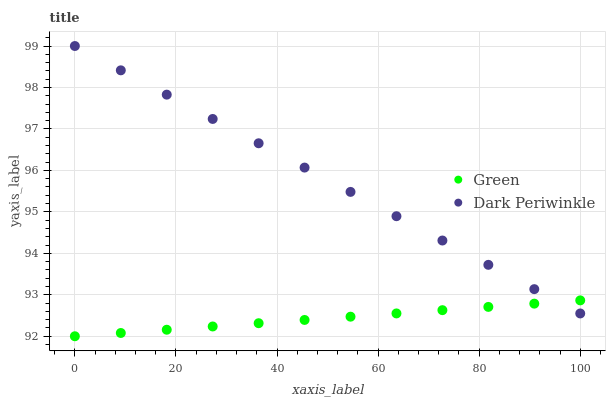Does Green have the minimum area under the curve?
Answer yes or no. Yes. Does Dark Periwinkle have the maximum area under the curve?
Answer yes or no. Yes. Does Dark Periwinkle have the minimum area under the curve?
Answer yes or no. No. Is Dark Periwinkle the smoothest?
Answer yes or no. Yes. Is Green the roughest?
Answer yes or no. Yes. Is Dark Periwinkle the roughest?
Answer yes or no. No. Does Green have the lowest value?
Answer yes or no. Yes. Does Dark Periwinkle have the lowest value?
Answer yes or no. No. Does Dark Periwinkle have the highest value?
Answer yes or no. Yes. Does Green intersect Dark Periwinkle?
Answer yes or no. Yes. Is Green less than Dark Periwinkle?
Answer yes or no. No. Is Green greater than Dark Periwinkle?
Answer yes or no. No. 